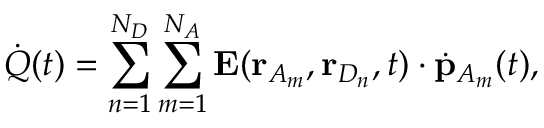Convert formula to latex. <formula><loc_0><loc_0><loc_500><loc_500>\dot { Q } ( t ) = \sum _ { n = 1 } ^ { N _ { D } } \sum _ { m = 1 } ^ { N _ { A } } E ( r _ { A _ { m } } , r _ { D _ { n } } , t ) \cdot \dot { p } _ { A _ { m } } ( t ) ,</formula> 